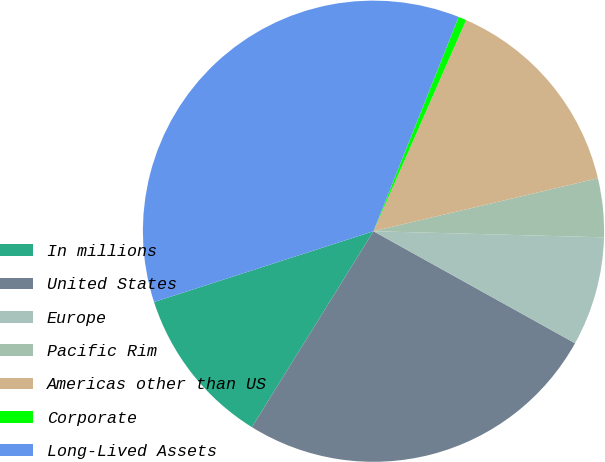<chart> <loc_0><loc_0><loc_500><loc_500><pie_chart><fcel>In millions<fcel>United States<fcel>Europe<fcel>Pacific Rim<fcel>Americas other than US<fcel>Corporate<fcel>Long-Lived Assets<nl><fcel>11.19%<fcel>25.77%<fcel>7.65%<fcel>4.11%<fcel>14.73%<fcel>0.56%<fcel>35.99%<nl></chart> 